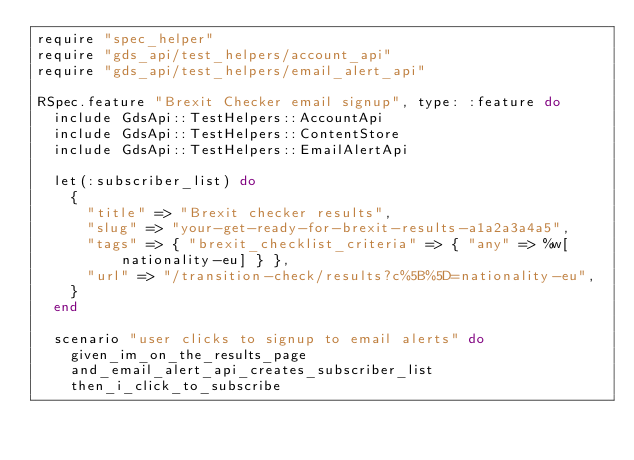<code> <loc_0><loc_0><loc_500><loc_500><_Ruby_>require "spec_helper"
require "gds_api/test_helpers/account_api"
require "gds_api/test_helpers/email_alert_api"

RSpec.feature "Brexit Checker email signup", type: :feature do
  include GdsApi::TestHelpers::AccountApi
  include GdsApi::TestHelpers::ContentStore
  include GdsApi::TestHelpers::EmailAlertApi

  let(:subscriber_list) do
    {
      "title" => "Brexit checker results",
      "slug" => "your-get-ready-for-brexit-results-a1a2a3a4a5",
      "tags" => { "brexit_checklist_criteria" => { "any" => %w[nationality-eu] } },
      "url" => "/transition-check/results?c%5B%5D=nationality-eu",
    }
  end

  scenario "user clicks to signup to email alerts" do
    given_im_on_the_results_page
    and_email_alert_api_creates_subscriber_list
    then_i_click_to_subscribe</code> 